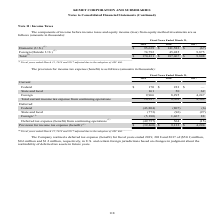From Kemet Corporation's financial document, Which years does the table provide information for the components of income before income taxes and equity income (loss) from equity method investments? The document contains multiple relevant values: 2019, 2018, 2017. From the document: "2019 2018 2017 2019 2018 2017 2019 2018 2017..." Also, What was the income from U.S. in 2017? According to the financial document, (67) (in thousands). The relevant text states: "Domestic (U.S.) (1) $ 95,639 $ 141,582 $ (67)..." Also, What was the total income in 2019? According to the financial document, 170,431 (in thousands). The relevant text states: "Total (1) $ 170,431 $ 187,067 $ 9,808..." Also, can you calculate: What was the change in Foreign income between 2017 and 2018? Based on the calculation: 45,485-9,875, the result is 35610 (in thousands). This is based on the information: "Foreign (Outside U.S.) (1) 74,792 45,485 9,875 Foreign (Outside U.S.) (1) 74,792 45,485 9,875..." The key data points involved are: 45,485, 9,875. Also, How many years did Domestic (U.S.) income exceed $100,000 thousand? Based on the analysis, there are 1 instances. The counting process: 2018. Also, can you calculate: What was the percentage change in total income between 2018 and 2019? To answer this question, I need to perform calculations using the financial data. The calculation is: (170,431-187,067)/187,067, which equals -8.89 (percentage). This is based on the information: "Total (1) $ 170,431 $ 187,067 $ 9,808 Total (1) $ 170,431 $ 187,067 $ 9,808..." The key data points involved are: 170,431, 187,067. 